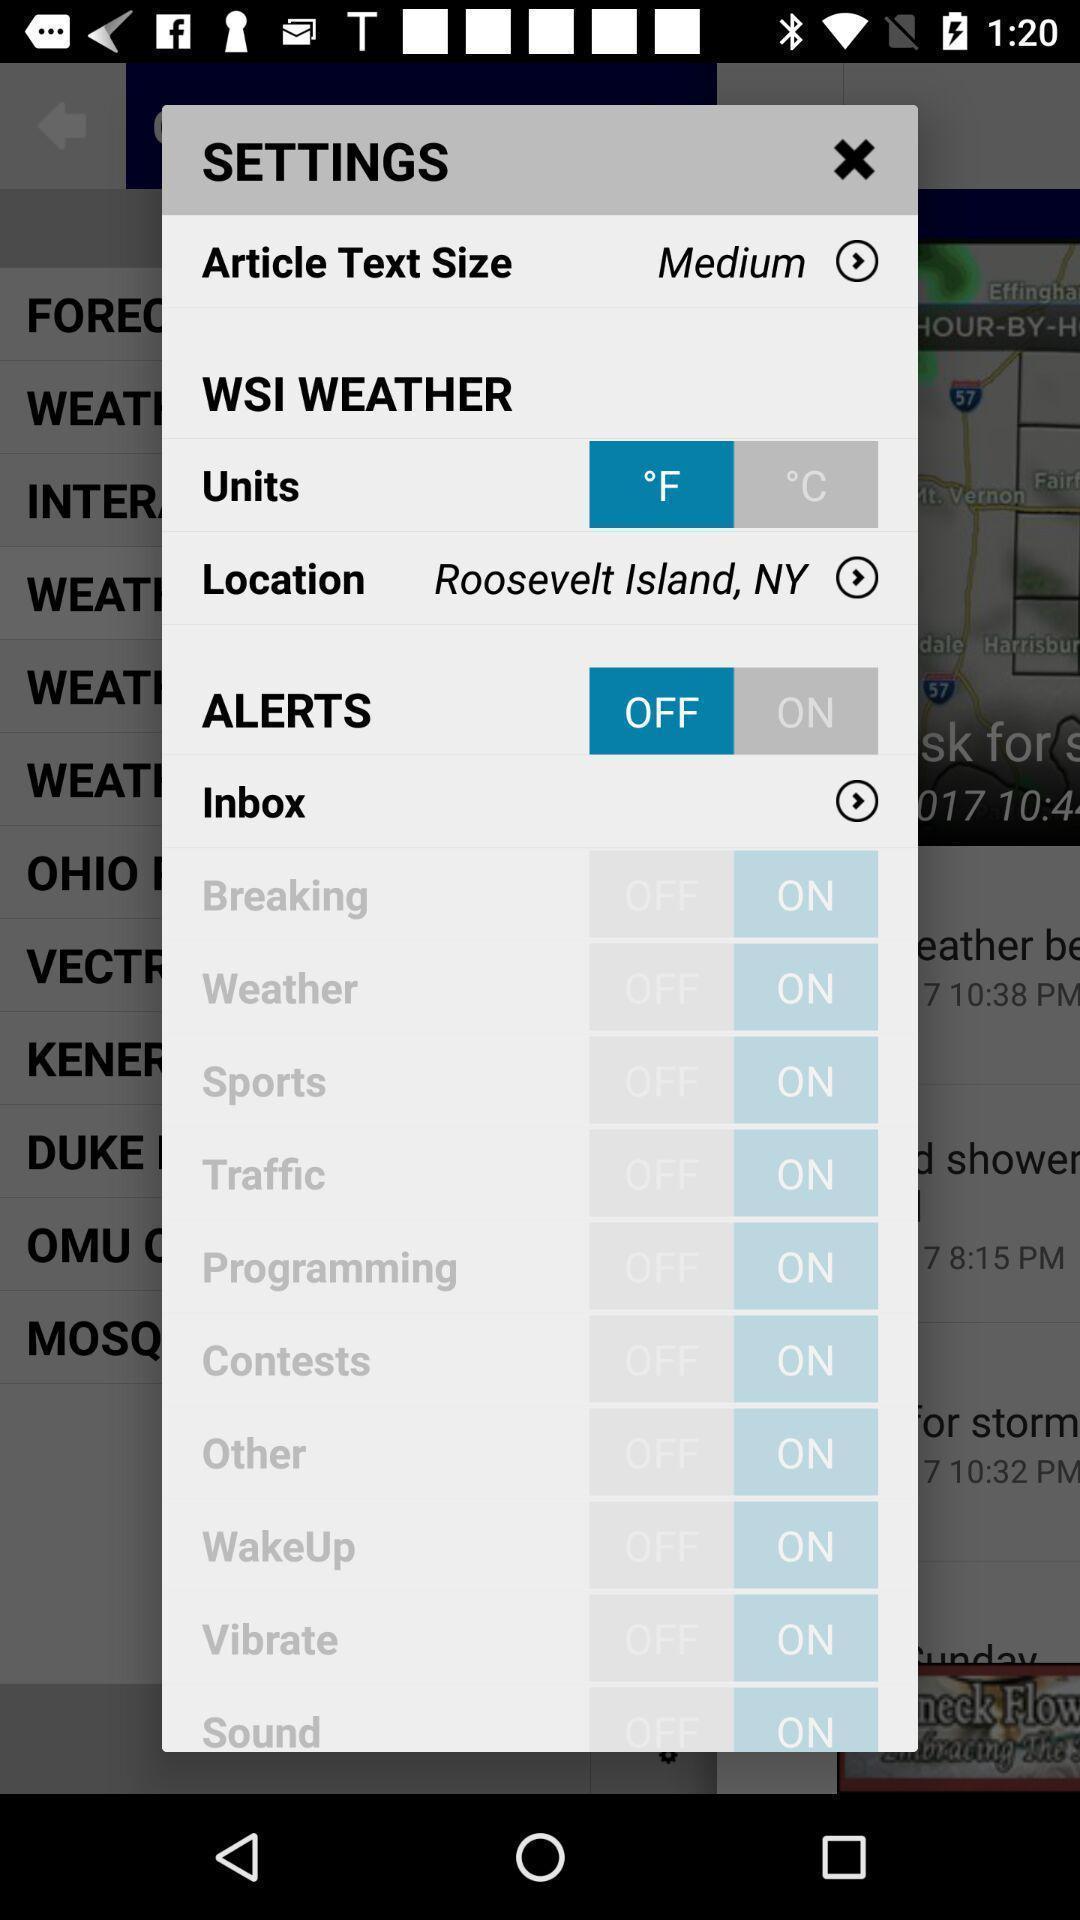Describe the key features of this screenshot. Popup showing weather settings. 